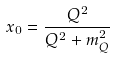Convert formula to latex. <formula><loc_0><loc_0><loc_500><loc_500>x _ { 0 } = \frac { Q ^ { 2 } } { Q ^ { 2 } + m _ { Q } ^ { 2 } }</formula> 